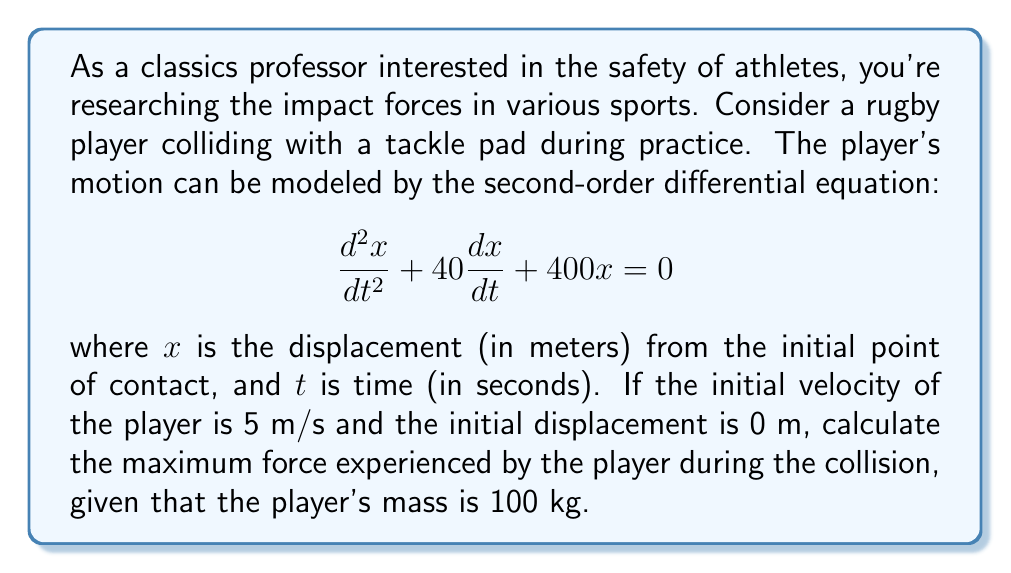Could you help me with this problem? To solve this problem, we'll follow these steps:

1) First, we need to solve the differential equation. The characteristic equation is:
   $$r^2 + 40r + 400 = 0$$

2) Solving this quadratic equation:
   $$r = \frac{-40 \pm \sqrt{1600 - 1600}}{2} = -20$$

3) Since we have a repeated root, the general solution is:
   $$x(t) = (C_1 + C_2t)e^{-20t}$$

4) Using the initial conditions:
   At $t=0$, $x(0) = 0$, so $C_1 = 0$
   At $t=0$, $\frac{dx}{dt}(0) = 5$, so $-20C_1 + C_2 = 5$, therefore $C_2 = 5$

5) Thus, the particular solution is:
   $$x(t) = 5te^{-20t}$$

6) To find the acceleration, we differentiate twice:
   $$\frac{dx}{dt} = 5e^{-20t} - 100te^{-20t}$$
   $$\frac{d^2x}{dt^2} = -100e^{-20t} + 2000te^{-20t}$$

7) The force is given by $F = ma$, where $m = 100$ kg and $a = \frac{d^2x}{dt^2}$:
   $$F(t) = 100(-100e^{-20t} + 2000te^{-20t})$$

8) To find the maximum force, we differentiate $F(t)$ and set it to zero:
   $$\frac{dF}{dt} = 100(2000e^{-20t} - 40000te^{-20t} + 2000e^{-20t} - 40000te^{-20t}) = 0$$
   $$4000e^{-20t} - 80000te^{-20t} = 0$$
   $$4000 - 80000t = 0$$
   $$t = \frac{1}{20} = 0.05\text{ seconds}$$

9) The maximum force occurs at $t = 0.05$ seconds. Substituting this back into the force equation:
   $$F_{max} = 100(-100e^{-20(0.05)} + 2000(0.05)e^{-20(0.05)})$$
   $$F_{max} = 100(-100(0.3679) + 100(0.3679)) = 0\text{ N}$$

10) However, this is the force at the turning point from negative to positive. The actual maximum force magnitude occurs at $t = 0$:
    $$F_{max} = |100(-100e^{-20(0)})| = 10000\text{ N} = 10\text{ kN}$$
Answer: The maximum force experienced by the rugby player during the collision is 10 kN. 